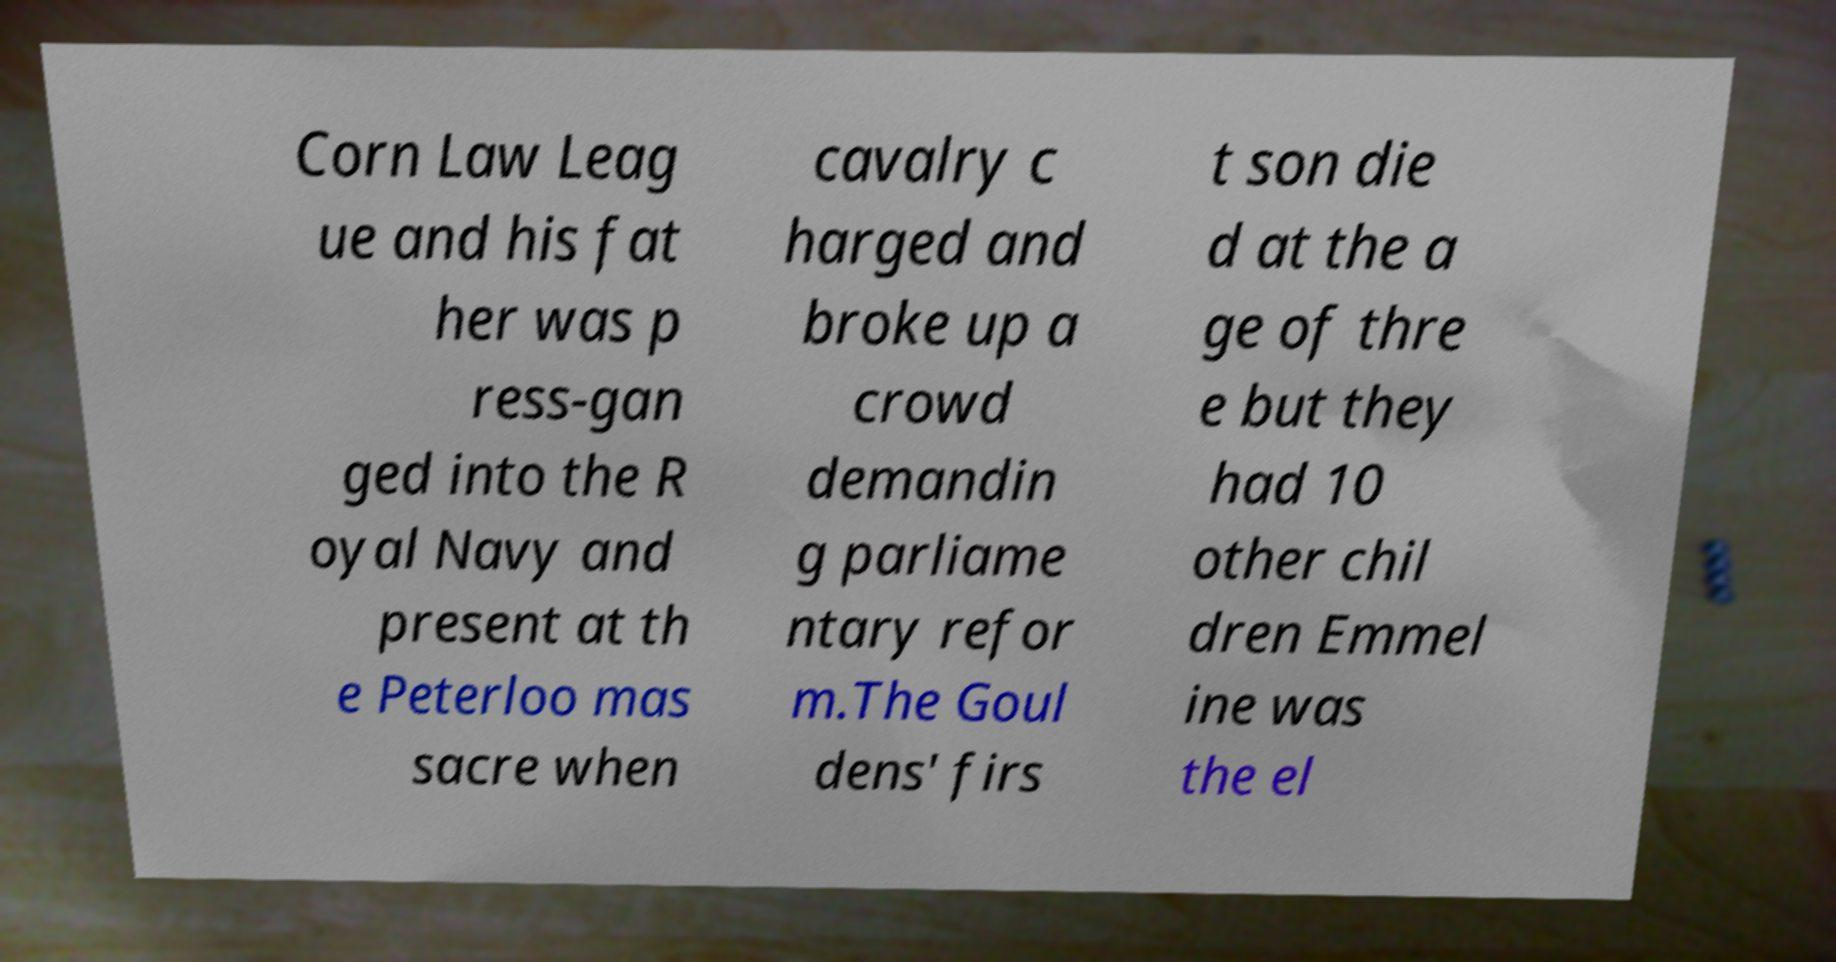There's text embedded in this image that I need extracted. Can you transcribe it verbatim? Corn Law Leag ue and his fat her was p ress-gan ged into the R oyal Navy and present at th e Peterloo mas sacre when cavalry c harged and broke up a crowd demandin g parliame ntary refor m.The Goul dens' firs t son die d at the a ge of thre e but they had 10 other chil dren Emmel ine was the el 